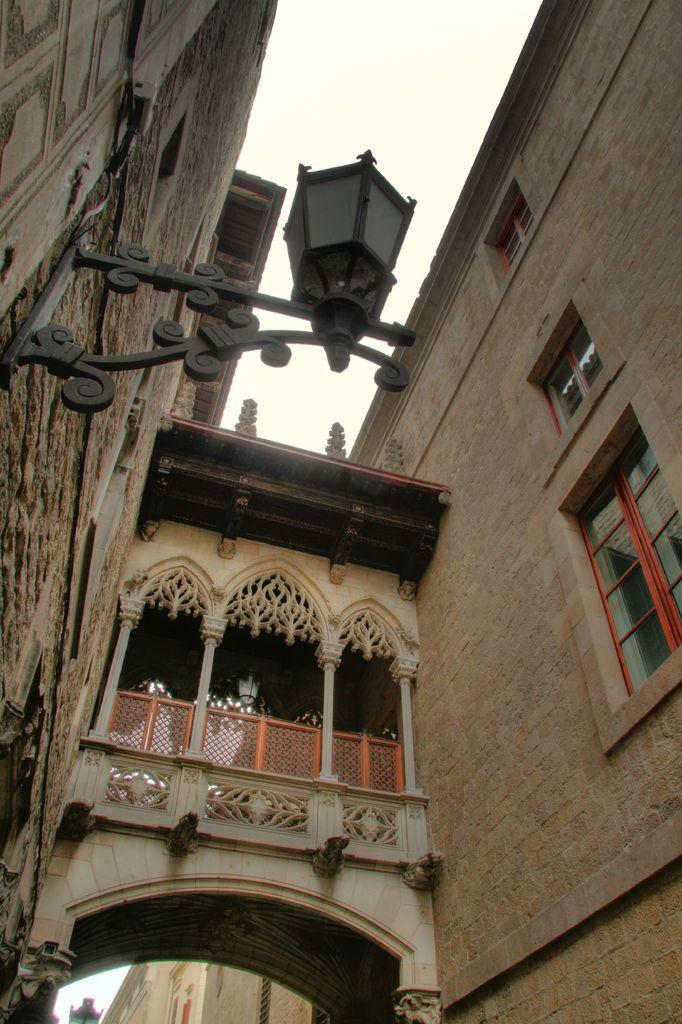Where was the picture taken? The picture was clicked outside. What can be seen in the image besides the outdoor setting? There are buildings, windows, a lamppost, a railing, and pillars in the image. What is visible in the background of the image? The sky is visible in the background of the image. Can you describe any other objects present in the image? There are other objects in the image, but their specific details are not mentioned in the provided facts. What type of payment is being made in the image? There is no indication of any payment being made in the image. What is the name of the downtown area visible in the image? The provided facts do not mention any specific downtown area or location. 